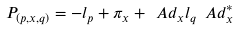Convert formula to latex. <formula><loc_0><loc_0><loc_500><loc_500>P _ { ( p , x , q ) } = - l _ { p } + \pi _ { x } + \ A d _ { x } l _ { q } \ A d ^ { * } _ { x }</formula> 